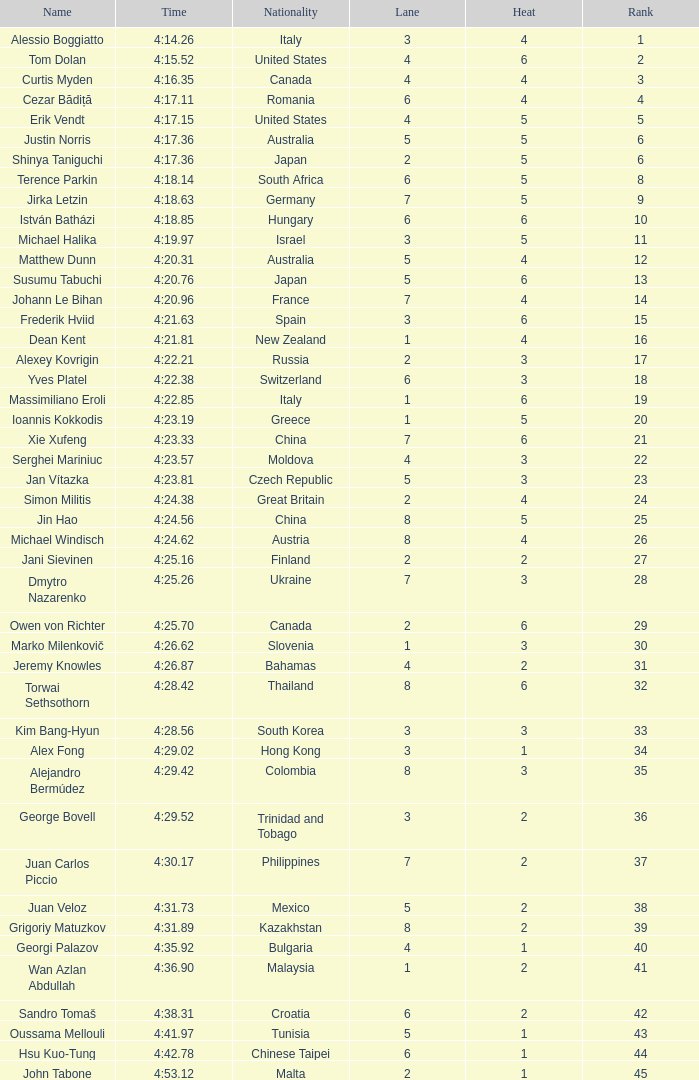Who was the 4 lane person from Canada? 4.0. 